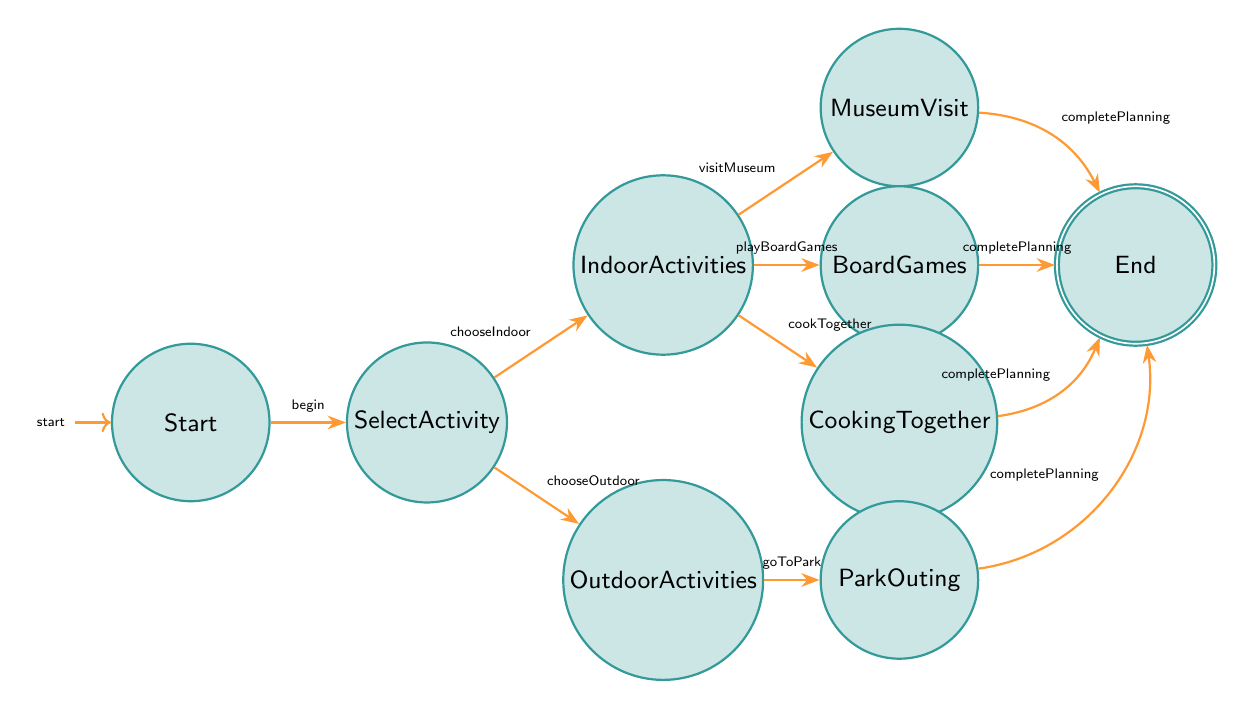What is the starting point in the diagram? The diagram begins with the "Start" node, which is designated as the initial state. This is explicitly labeled in the diagram.
Answer: Start How many activity options are available after selecting an activity? After the "SelectActivity" node, the options available are "IndoorActivities" and "OutdoorActivities". There are two distinct branches emerging from the "SelectActivity" node.
Answer: 2 What activity option is related to the trigger "goToPark"? The "goToPark" trigger leads directly to the "ParkOuting" node from the "OutdoorActivities" node. This connection specifies that this trigger is associated with the outdoor activity option.
Answer: Park Outing List one transition that leads to the "End" state. Several transitions lead to the "End" state, one of which is from the "MuseumVisit" node with the trigger "completePlanning". This indicates that after the planning of a museum visit is done, it moves to the end state.
Answer: completePlanning What are the indoor activities listed in the diagram? The indoor activities are denoted by three nodes stemming from "IndoorActivities": "MuseumVisit", "BoardGames", and "CookingTogether". Each of these activities provides an option for planning indoor family engagements.
Answer: Museum Visit, Board Games, Cooking Together If someone chooses to "playBoardGames", what is the next step in the diagram? If the trigger "playBoardGames" is activated, it transitions from the "IndoorActivities" node to the "BoardGames" node, and completing this activity will take you to the "End" node through the "completePlanning" transition.
Answer: End How many nodes lead to the "completePlanning" transition? There are four activity nodes that lead to the "completePlanning" transition, specifically from "MuseumVisit", "BoardGames", "CookingTogether", and "ParkOuting". This indicates that these activities can all finalize planning the weekend's activities.
Answer: 4 What is a transition that allows selection of indoor activities? The transition leading to indoor activities is marked by the trigger "chooseIndoor", allowing the user to move from the "SelectActivity" node to "IndoorActivities". This shows the decision-making path towards planning activities indoors.
Answer: chooseIndoor What is the final state of the finite state machine? The finite state machine concludes with the "End" node, which represents the completion of the planning process, signifying that all chosen activities have been successfully organized.
Answer: End 